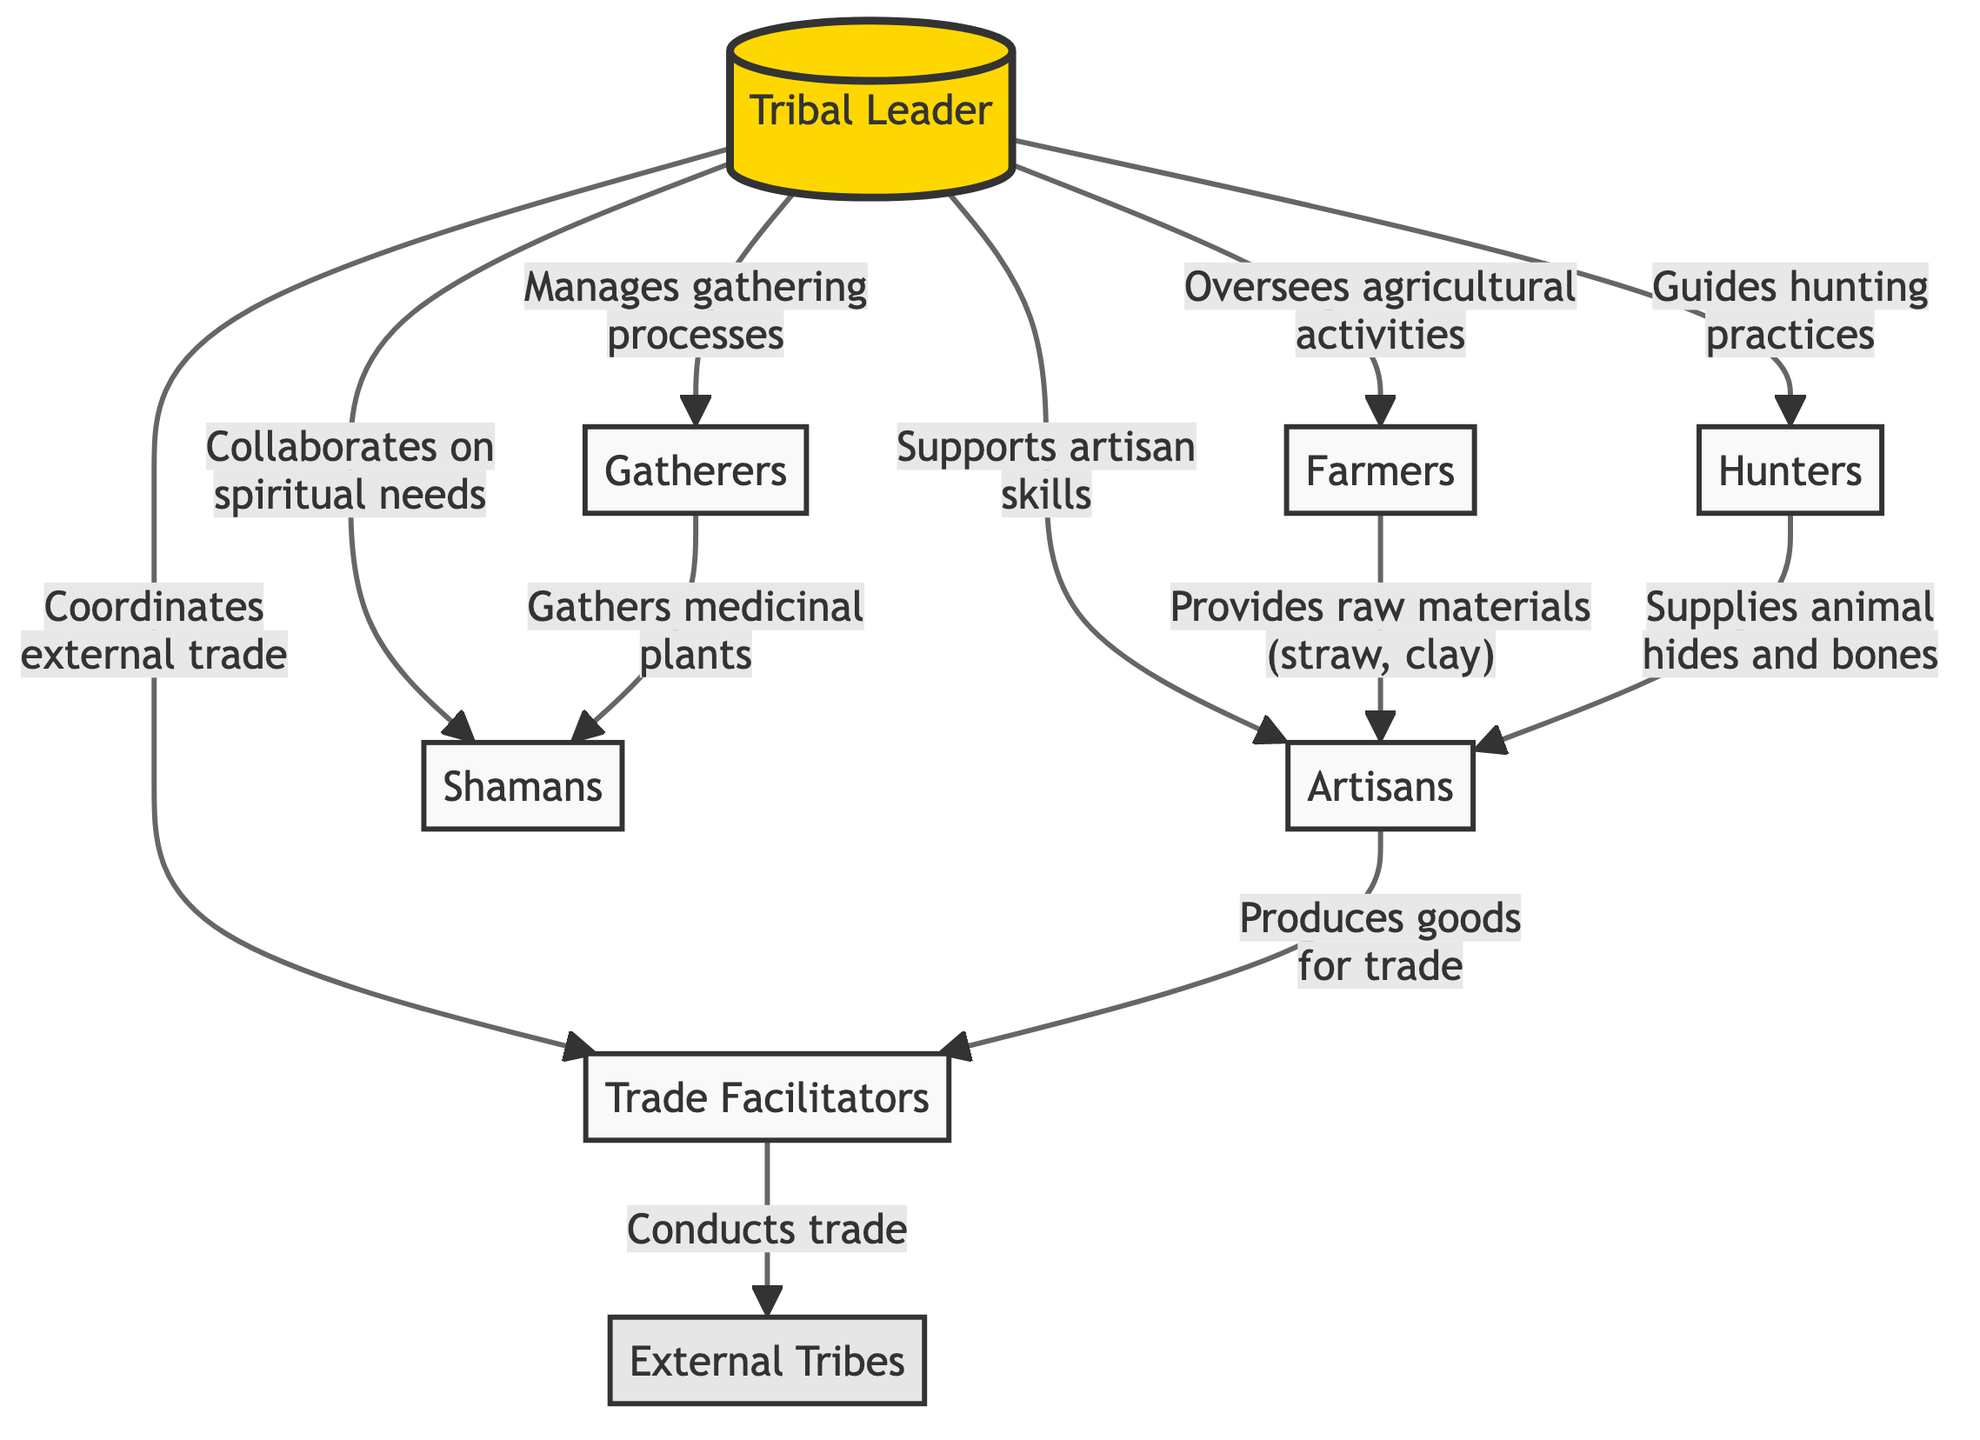What is the top node in the diagram? The top node is labeled as "Tribal Leader," indicating the highest position in the hierarchical structure of economic exchange systems in tribal communities.
Answer: Tribal Leader How many different roles are represented in the diagram? The diagram includes a total of six roles beneath the Tribal Leader, which are Farmers, Hunters, Gatherers, Artisans, Shamans, and Trade Facilitators, plus one external role, making it a total of seven roles.
Answer: Seven Which group provides raw materials like straw and clay? The Farmers are indicated as the group that provides raw materials such as straw and clay to the Artisans, as shown by the directed edge from Farmers to Artisans.
Answer: Farmers Who collaborates on spiritual needs? The Tribal Leader collaborates with the Shamans on spiritual needs, as illustrated by the connection from the Tribal Leader to Shamans in the diagram.
Answer: Shamans What goods do Artisans produce for trade? Artisans produce goods for trade, which is explicitly stated in the diagram's connection between Artisans and Trade Facilitators.
Answer: Goods for trade Which role is responsible for conducting trade with external tribes? The role responsible for conducting trade with external tribes is designated as Trade Facilitators, who manage trade relationships as shown in the diagram.
Answer: Trade Facilitators What do Gatherers supply to Shamans? Gatherers supply medicinal plants to Shamans, as indicated by the direct link from Gatherers to Shamans in the diagram.
Answer: Medicinal plants How does the Tribal Leader oversee agricultural activities? The Tribal Leader oversees agricultural activities by connecting with the Farmers, who are directly influenced and guided by the Tribal Leader's decisions and actions.
Answer: Farmers Which group supplies animal hides and bones? Hunters are identified as the group that supplies animal hides and bones, as per the relationship directed from Hunters to Artisans in the diagram.
Answer: Hunters 